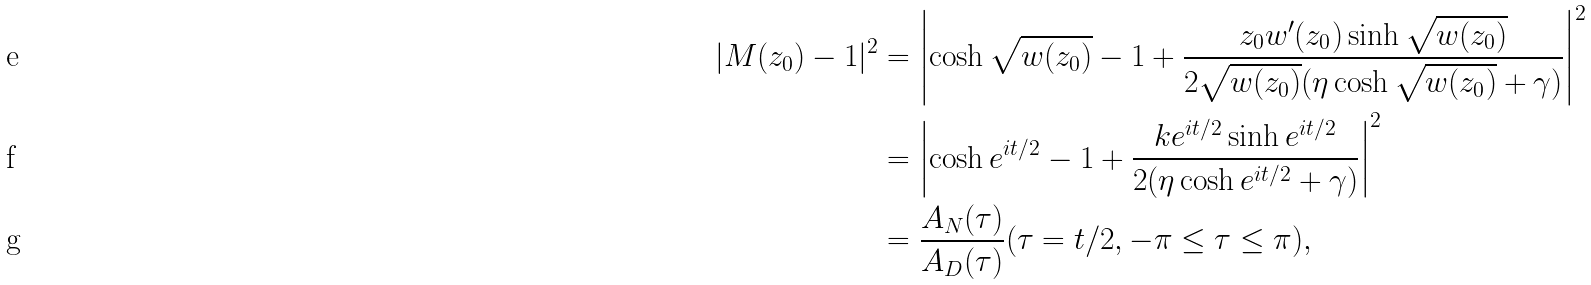<formula> <loc_0><loc_0><loc_500><loc_500>| M ( z _ { 0 } ) - 1 | ^ { 2 } & = \left | \cosh \sqrt { w ( z _ { 0 } ) } - 1 + \frac { z _ { 0 } w ^ { \prime } ( z _ { 0 } ) \sinh \sqrt { w ( z _ { 0 } ) } } { 2 \sqrt { w ( z _ { 0 } ) } ( \eta \cosh \sqrt { w ( z _ { 0 } ) } + \gamma ) } \right | ^ { 2 } \\ & = \left | \cosh e ^ { i t / 2 } - 1 + \frac { k e ^ { i t / 2 } \sinh e ^ { i t / 2 } } { 2 ( \eta \cosh e ^ { i t / 2 } + \gamma ) } \right | ^ { 2 } \\ & = \frac { A _ { N } ( \tau ) } { A _ { D } ( \tau ) } ( \tau = t / 2 , - \pi \leq \tau \leq \pi ) ,</formula> 